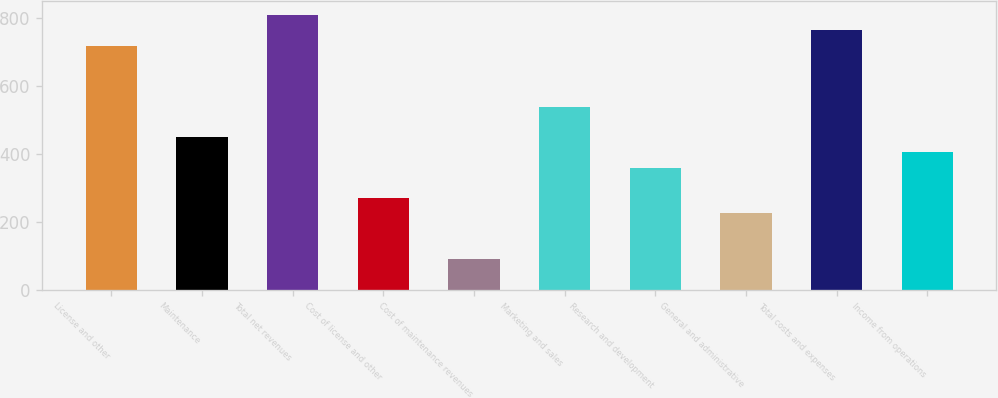Convert chart. <chart><loc_0><loc_0><loc_500><loc_500><bar_chart><fcel>License and other<fcel>Maintenance<fcel>Total net revenues<fcel>Cost of license and other<fcel>Cost of maintenance revenues<fcel>Marketing and sales<fcel>Research and development<fcel>General and administrative<fcel>Total costs and expenses<fcel>Income from operations<nl><fcel>719.08<fcel>449.56<fcel>808.92<fcel>269.88<fcel>90.2<fcel>539.4<fcel>359.72<fcel>224.96<fcel>764<fcel>404.64<nl></chart> 